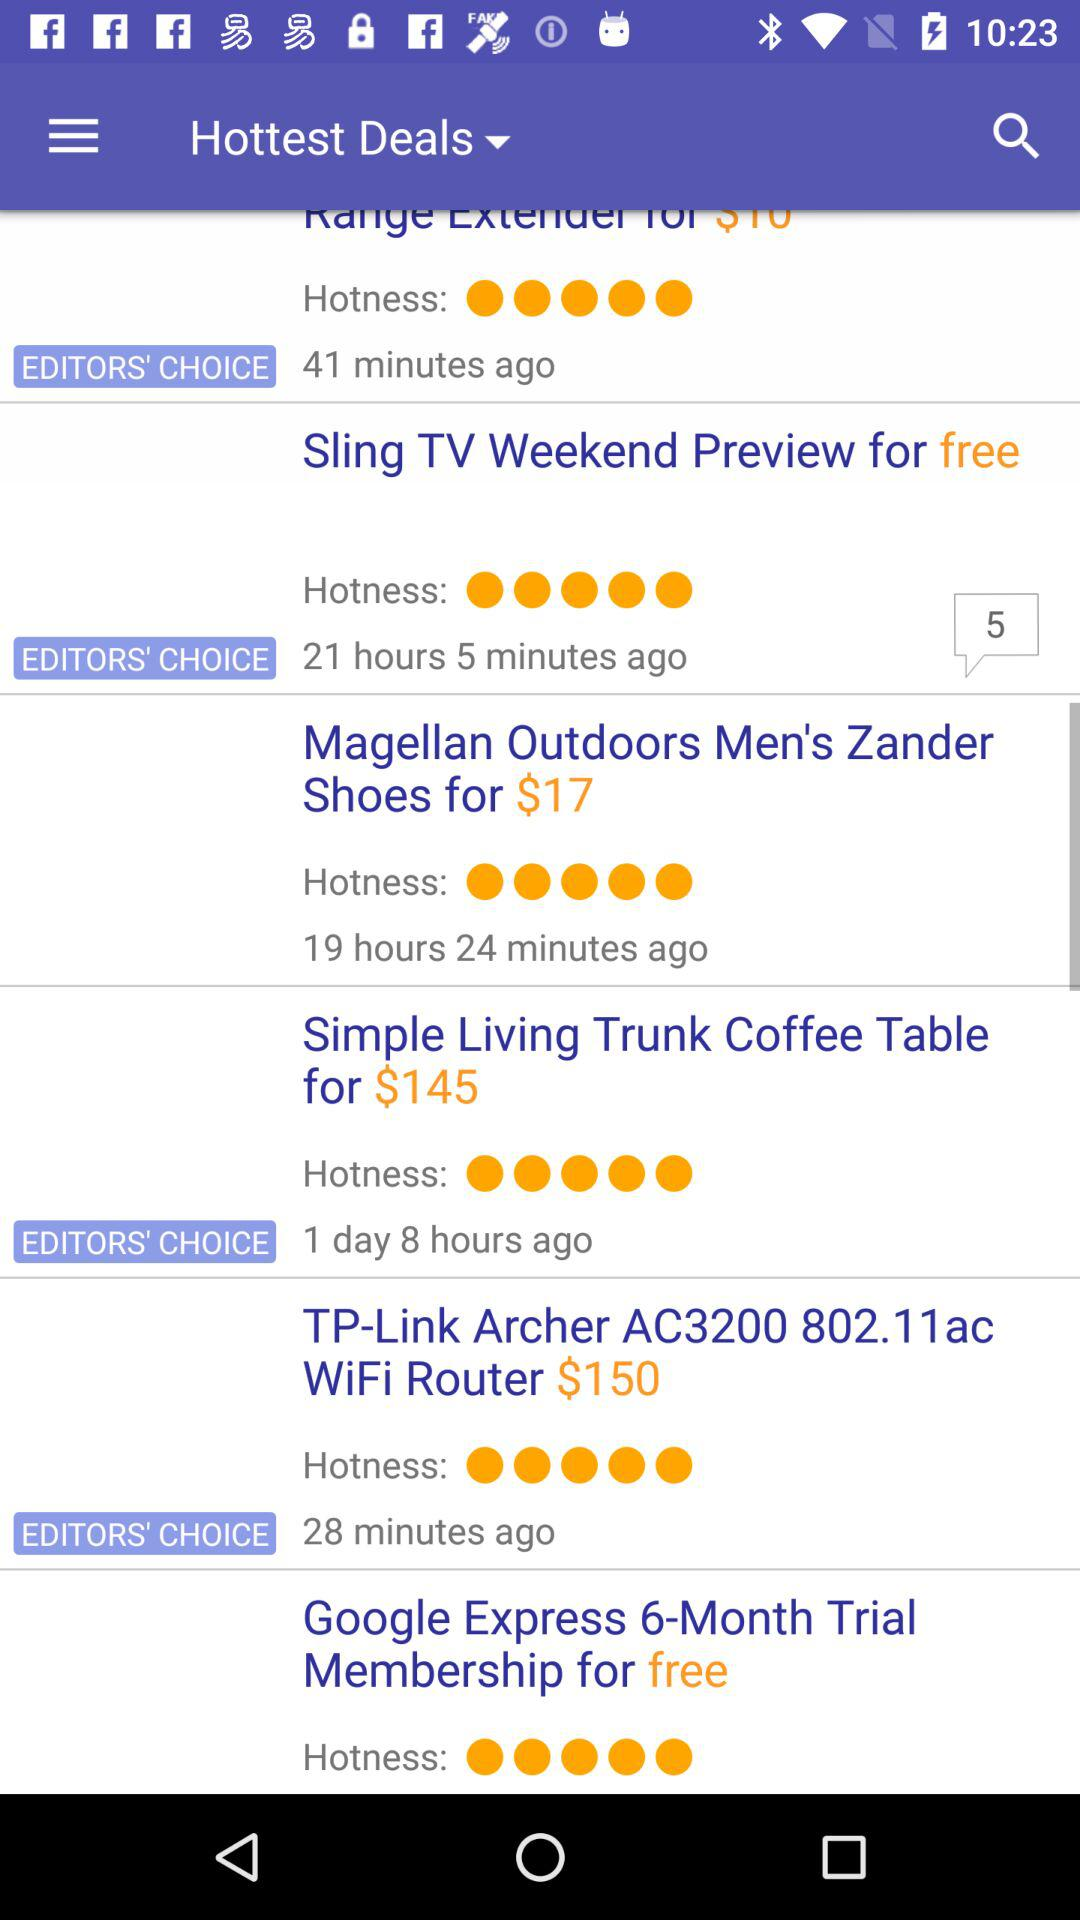What is the price of "Magellan Outdoors Men's Zander Shoes"? The price is $17. 